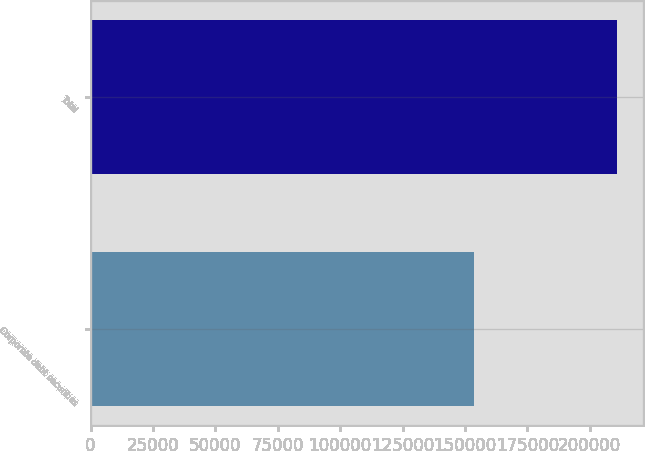Convert chart to OTSL. <chart><loc_0><loc_0><loc_500><loc_500><bar_chart><fcel>Corporate debt securities<fcel>Total<nl><fcel>153547<fcel>210870<nl></chart> 